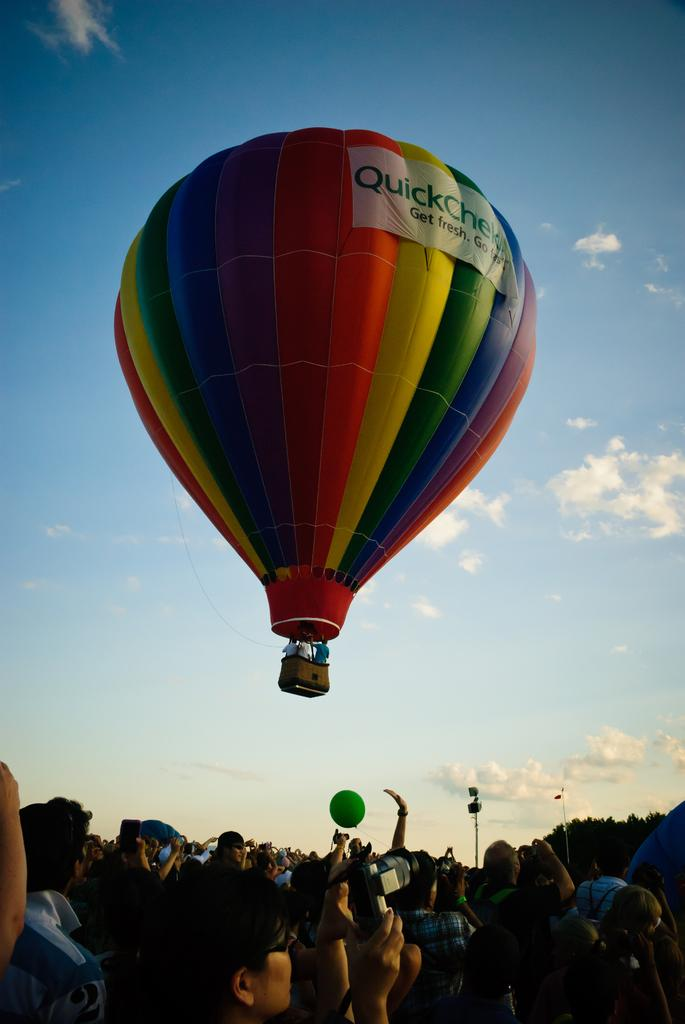What is the main subject of the image? The main subject of the image is a hot air balloon. Where is the hot air balloon located in the image? The hot air balloon is in the air. What are the people below the hot air balloon doing? The people are taking pictures. What can be seen in the sky in the image? The sky is visible in the image, and clouds are present. What type of eggnog is being served in the hot air balloon? There is no eggnog present in the image, as it features a hot air balloon in the air with people taking pictures below. 